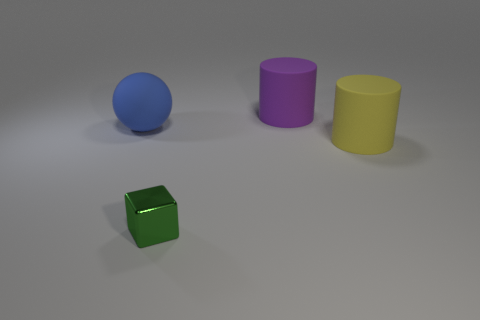The large matte thing behind the object that is left of the tiny thing that is in front of the purple rubber thing is what shape?
Keep it short and to the point. Cylinder. What size is the object that is in front of the big yellow matte cylinder?
Your answer should be very brief. Small. There is a blue matte object that is the same size as the purple thing; what is its shape?
Ensure brevity in your answer.  Sphere. How many objects are either cylinders or large rubber things behind the blue object?
Provide a succinct answer. 2. There is a cylinder in front of the big object that is on the left side of the tiny green object; what number of big purple rubber cylinders are left of it?
Provide a succinct answer. 1. What color is the large sphere that is made of the same material as the yellow object?
Keep it short and to the point. Blue. Does the cylinder in front of the blue ball have the same size as the large matte ball?
Make the answer very short. Yes. How many objects are tiny green cylinders or cylinders?
Keep it short and to the point. 2. The large cylinder in front of the large cylinder behind the large rubber cylinder that is in front of the blue matte thing is made of what material?
Provide a short and direct response. Rubber. There is a large cylinder on the left side of the big yellow rubber cylinder; what is it made of?
Provide a short and direct response. Rubber. 